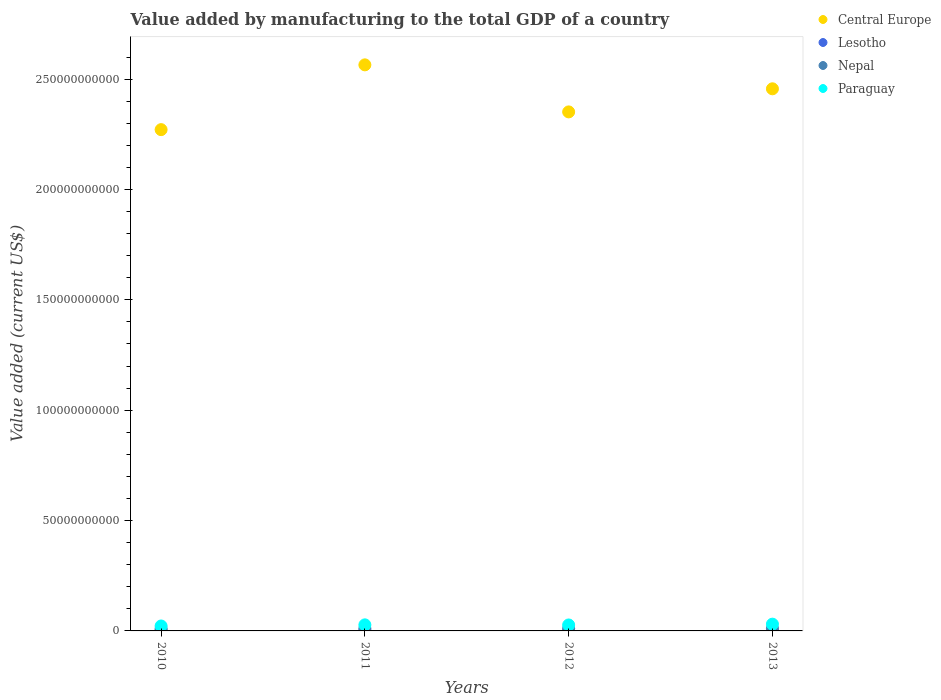How many different coloured dotlines are there?
Keep it short and to the point. 4. What is the value added by manufacturing to the total GDP in Central Europe in 2010?
Your answer should be compact. 2.27e+11. Across all years, what is the maximum value added by manufacturing to the total GDP in Nepal?
Keep it short and to the point. 1.14e+09. Across all years, what is the minimum value added by manufacturing to the total GDP in Central Europe?
Make the answer very short. 2.27e+11. What is the total value added by manufacturing to the total GDP in Paraguay in the graph?
Provide a succinct answer. 1.08e+1. What is the difference between the value added by manufacturing to the total GDP in Lesotho in 2010 and that in 2013?
Offer a terse response. 7.15e+07. What is the difference between the value added by manufacturing to the total GDP in Central Europe in 2013 and the value added by manufacturing to the total GDP in Paraguay in 2010?
Your answer should be very brief. 2.43e+11. What is the average value added by manufacturing to the total GDP in Central Europe per year?
Ensure brevity in your answer.  2.41e+11. In the year 2011, what is the difference between the value added by manufacturing to the total GDP in Lesotho and value added by manufacturing to the total GDP in Central Europe?
Provide a short and direct response. -2.56e+11. In how many years, is the value added by manufacturing to the total GDP in Paraguay greater than 70000000000 US$?
Provide a short and direct response. 0. What is the ratio of the value added by manufacturing to the total GDP in Paraguay in 2011 to that in 2013?
Your answer should be very brief. 0.9. Is the value added by manufacturing to the total GDP in Central Europe in 2011 less than that in 2013?
Provide a short and direct response. No. What is the difference between the highest and the second highest value added by manufacturing to the total GDP in Central Europe?
Your response must be concise. 1.08e+1. What is the difference between the highest and the lowest value added by manufacturing to the total GDP in Lesotho?
Offer a terse response. 7.15e+07. Is it the case that in every year, the sum of the value added by manufacturing to the total GDP in Lesotho and value added by manufacturing to the total GDP in Central Europe  is greater than the value added by manufacturing to the total GDP in Paraguay?
Keep it short and to the point. Yes. How many dotlines are there?
Make the answer very short. 4. Are the values on the major ticks of Y-axis written in scientific E-notation?
Your answer should be compact. No. Does the graph contain any zero values?
Offer a terse response. No. Where does the legend appear in the graph?
Keep it short and to the point. Top right. What is the title of the graph?
Offer a terse response. Value added by manufacturing to the total GDP of a country. What is the label or title of the X-axis?
Your response must be concise. Years. What is the label or title of the Y-axis?
Offer a very short reply. Value added (current US$). What is the Value added (current US$) in Central Europe in 2010?
Your answer should be compact. 2.27e+11. What is the Value added (current US$) of Lesotho in 2010?
Offer a terse response. 2.76e+08. What is the Value added (current US$) in Nepal in 2010?
Offer a terse response. 9.52e+08. What is the Value added (current US$) of Paraguay in 2010?
Your answer should be very brief. 2.24e+09. What is the Value added (current US$) of Central Europe in 2011?
Your response must be concise. 2.56e+11. What is the Value added (current US$) of Lesotho in 2011?
Offer a terse response. 2.64e+08. What is the Value added (current US$) of Nepal in 2011?
Your answer should be very brief. 1.11e+09. What is the Value added (current US$) in Paraguay in 2011?
Ensure brevity in your answer.  2.75e+09. What is the Value added (current US$) of Central Europe in 2012?
Provide a succinct answer. 2.35e+11. What is the Value added (current US$) of Lesotho in 2012?
Give a very brief answer. 2.41e+08. What is the Value added (current US$) of Nepal in 2012?
Offer a terse response. 1.13e+09. What is the Value added (current US$) in Paraguay in 2012?
Keep it short and to the point. 2.70e+09. What is the Value added (current US$) in Central Europe in 2013?
Your response must be concise. 2.46e+11. What is the Value added (current US$) in Lesotho in 2013?
Your answer should be compact. 2.04e+08. What is the Value added (current US$) in Nepal in 2013?
Your answer should be compact. 1.14e+09. What is the Value added (current US$) in Paraguay in 2013?
Make the answer very short. 3.06e+09. Across all years, what is the maximum Value added (current US$) in Central Europe?
Your answer should be compact. 2.56e+11. Across all years, what is the maximum Value added (current US$) of Lesotho?
Offer a terse response. 2.76e+08. Across all years, what is the maximum Value added (current US$) in Nepal?
Keep it short and to the point. 1.14e+09. Across all years, what is the maximum Value added (current US$) in Paraguay?
Provide a short and direct response. 3.06e+09. Across all years, what is the minimum Value added (current US$) of Central Europe?
Ensure brevity in your answer.  2.27e+11. Across all years, what is the minimum Value added (current US$) of Lesotho?
Give a very brief answer. 2.04e+08. Across all years, what is the minimum Value added (current US$) of Nepal?
Make the answer very short. 9.52e+08. Across all years, what is the minimum Value added (current US$) of Paraguay?
Offer a very short reply. 2.24e+09. What is the total Value added (current US$) of Central Europe in the graph?
Provide a short and direct response. 9.64e+11. What is the total Value added (current US$) in Lesotho in the graph?
Offer a very short reply. 9.85e+08. What is the total Value added (current US$) in Nepal in the graph?
Make the answer very short. 4.33e+09. What is the total Value added (current US$) of Paraguay in the graph?
Keep it short and to the point. 1.08e+1. What is the difference between the Value added (current US$) in Central Europe in 2010 and that in 2011?
Offer a very short reply. -2.93e+1. What is the difference between the Value added (current US$) of Lesotho in 2010 and that in 2011?
Offer a very short reply. 1.19e+07. What is the difference between the Value added (current US$) of Nepal in 2010 and that in 2011?
Provide a short and direct response. -1.63e+08. What is the difference between the Value added (current US$) in Paraguay in 2010 and that in 2011?
Your response must be concise. -5.10e+08. What is the difference between the Value added (current US$) in Central Europe in 2010 and that in 2012?
Your answer should be compact. -8.04e+09. What is the difference between the Value added (current US$) of Lesotho in 2010 and that in 2012?
Keep it short and to the point. 3.45e+07. What is the difference between the Value added (current US$) in Nepal in 2010 and that in 2012?
Your answer should be very brief. -1.74e+08. What is the difference between the Value added (current US$) in Paraguay in 2010 and that in 2012?
Keep it short and to the point. -4.61e+08. What is the difference between the Value added (current US$) of Central Europe in 2010 and that in 2013?
Provide a short and direct response. -1.85e+1. What is the difference between the Value added (current US$) in Lesotho in 2010 and that in 2013?
Provide a short and direct response. 7.15e+07. What is the difference between the Value added (current US$) in Nepal in 2010 and that in 2013?
Provide a succinct answer. -1.89e+08. What is the difference between the Value added (current US$) of Paraguay in 2010 and that in 2013?
Offer a very short reply. -8.23e+08. What is the difference between the Value added (current US$) of Central Europe in 2011 and that in 2012?
Ensure brevity in your answer.  2.13e+1. What is the difference between the Value added (current US$) in Lesotho in 2011 and that in 2012?
Keep it short and to the point. 2.26e+07. What is the difference between the Value added (current US$) of Nepal in 2011 and that in 2012?
Offer a very short reply. -1.10e+07. What is the difference between the Value added (current US$) of Paraguay in 2011 and that in 2012?
Make the answer very short. 4.88e+07. What is the difference between the Value added (current US$) in Central Europe in 2011 and that in 2013?
Your answer should be very brief. 1.08e+1. What is the difference between the Value added (current US$) of Lesotho in 2011 and that in 2013?
Your answer should be compact. 5.96e+07. What is the difference between the Value added (current US$) of Nepal in 2011 and that in 2013?
Make the answer very short. -2.62e+07. What is the difference between the Value added (current US$) of Paraguay in 2011 and that in 2013?
Your answer should be very brief. -3.13e+08. What is the difference between the Value added (current US$) in Central Europe in 2012 and that in 2013?
Keep it short and to the point. -1.05e+1. What is the difference between the Value added (current US$) in Lesotho in 2012 and that in 2013?
Your answer should be compact. 3.70e+07. What is the difference between the Value added (current US$) of Nepal in 2012 and that in 2013?
Provide a succinct answer. -1.53e+07. What is the difference between the Value added (current US$) of Paraguay in 2012 and that in 2013?
Give a very brief answer. -3.62e+08. What is the difference between the Value added (current US$) of Central Europe in 2010 and the Value added (current US$) of Lesotho in 2011?
Make the answer very short. 2.27e+11. What is the difference between the Value added (current US$) in Central Europe in 2010 and the Value added (current US$) in Nepal in 2011?
Ensure brevity in your answer.  2.26e+11. What is the difference between the Value added (current US$) in Central Europe in 2010 and the Value added (current US$) in Paraguay in 2011?
Your answer should be very brief. 2.24e+11. What is the difference between the Value added (current US$) in Lesotho in 2010 and the Value added (current US$) in Nepal in 2011?
Your response must be concise. -8.38e+08. What is the difference between the Value added (current US$) in Lesotho in 2010 and the Value added (current US$) in Paraguay in 2011?
Your answer should be very brief. -2.47e+09. What is the difference between the Value added (current US$) in Nepal in 2010 and the Value added (current US$) in Paraguay in 2011?
Your response must be concise. -1.80e+09. What is the difference between the Value added (current US$) in Central Europe in 2010 and the Value added (current US$) in Lesotho in 2012?
Keep it short and to the point. 2.27e+11. What is the difference between the Value added (current US$) of Central Europe in 2010 and the Value added (current US$) of Nepal in 2012?
Your answer should be very brief. 2.26e+11. What is the difference between the Value added (current US$) of Central Europe in 2010 and the Value added (current US$) of Paraguay in 2012?
Offer a very short reply. 2.24e+11. What is the difference between the Value added (current US$) of Lesotho in 2010 and the Value added (current US$) of Nepal in 2012?
Give a very brief answer. -8.49e+08. What is the difference between the Value added (current US$) in Lesotho in 2010 and the Value added (current US$) in Paraguay in 2012?
Your response must be concise. -2.42e+09. What is the difference between the Value added (current US$) of Nepal in 2010 and the Value added (current US$) of Paraguay in 2012?
Provide a succinct answer. -1.75e+09. What is the difference between the Value added (current US$) in Central Europe in 2010 and the Value added (current US$) in Lesotho in 2013?
Provide a succinct answer. 2.27e+11. What is the difference between the Value added (current US$) in Central Europe in 2010 and the Value added (current US$) in Nepal in 2013?
Your answer should be very brief. 2.26e+11. What is the difference between the Value added (current US$) in Central Europe in 2010 and the Value added (current US$) in Paraguay in 2013?
Provide a short and direct response. 2.24e+11. What is the difference between the Value added (current US$) in Lesotho in 2010 and the Value added (current US$) in Nepal in 2013?
Keep it short and to the point. -8.65e+08. What is the difference between the Value added (current US$) in Lesotho in 2010 and the Value added (current US$) in Paraguay in 2013?
Keep it short and to the point. -2.79e+09. What is the difference between the Value added (current US$) of Nepal in 2010 and the Value added (current US$) of Paraguay in 2013?
Keep it short and to the point. -2.11e+09. What is the difference between the Value added (current US$) in Central Europe in 2011 and the Value added (current US$) in Lesotho in 2012?
Offer a very short reply. 2.56e+11. What is the difference between the Value added (current US$) in Central Europe in 2011 and the Value added (current US$) in Nepal in 2012?
Offer a terse response. 2.55e+11. What is the difference between the Value added (current US$) of Central Europe in 2011 and the Value added (current US$) of Paraguay in 2012?
Provide a short and direct response. 2.54e+11. What is the difference between the Value added (current US$) in Lesotho in 2011 and the Value added (current US$) in Nepal in 2012?
Ensure brevity in your answer.  -8.61e+08. What is the difference between the Value added (current US$) in Lesotho in 2011 and the Value added (current US$) in Paraguay in 2012?
Your answer should be compact. -2.44e+09. What is the difference between the Value added (current US$) of Nepal in 2011 and the Value added (current US$) of Paraguay in 2012?
Make the answer very short. -1.59e+09. What is the difference between the Value added (current US$) in Central Europe in 2011 and the Value added (current US$) in Lesotho in 2013?
Keep it short and to the point. 2.56e+11. What is the difference between the Value added (current US$) of Central Europe in 2011 and the Value added (current US$) of Nepal in 2013?
Provide a short and direct response. 2.55e+11. What is the difference between the Value added (current US$) of Central Europe in 2011 and the Value added (current US$) of Paraguay in 2013?
Your answer should be compact. 2.53e+11. What is the difference between the Value added (current US$) in Lesotho in 2011 and the Value added (current US$) in Nepal in 2013?
Offer a very short reply. -8.77e+08. What is the difference between the Value added (current US$) of Lesotho in 2011 and the Value added (current US$) of Paraguay in 2013?
Provide a short and direct response. -2.80e+09. What is the difference between the Value added (current US$) in Nepal in 2011 and the Value added (current US$) in Paraguay in 2013?
Your answer should be very brief. -1.95e+09. What is the difference between the Value added (current US$) of Central Europe in 2012 and the Value added (current US$) of Lesotho in 2013?
Give a very brief answer. 2.35e+11. What is the difference between the Value added (current US$) in Central Europe in 2012 and the Value added (current US$) in Nepal in 2013?
Your answer should be compact. 2.34e+11. What is the difference between the Value added (current US$) of Central Europe in 2012 and the Value added (current US$) of Paraguay in 2013?
Offer a terse response. 2.32e+11. What is the difference between the Value added (current US$) of Lesotho in 2012 and the Value added (current US$) of Nepal in 2013?
Give a very brief answer. -8.99e+08. What is the difference between the Value added (current US$) of Lesotho in 2012 and the Value added (current US$) of Paraguay in 2013?
Offer a terse response. -2.82e+09. What is the difference between the Value added (current US$) of Nepal in 2012 and the Value added (current US$) of Paraguay in 2013?
Offer a terse response. -1.94e+09. What is the average Value added (current US$) in Central Europe per year?
Your response must be concise. 2.41e+11. What is the average Value added (current US$) in Lesotho per year?
Keep it short and to the point. 2.46e+08. What is the average Value added (current US$) in Nepal per year?
Offer a terse response. 1.08e+09. What is the average Value added (current US$) of Paraguay per year?
Ensure brevity in your answer.  2.69e+09. In the year 2010, what is the difference between the Value added (current US$) of Central Europe and Value added (current US$) of Lesotho?
Provide a succinct answer. 2.27e+11. In the year 2010, what is the difference between the Value added (current US$) in Central Europe and Value added (current US$) in Nepal?
Keep it short and to the point. 2.26e+11. In the year 2010, what is the difference between the Value added (current US$) in Central Europe and Value added (current US$) in Paraguay?
Provide a succinct answer. 2.25e+11. In the year 2010, what is the difference between the Value added (current US$) of Lesotho and Value added (current US$) of Nepal?
Ensure brevity in your answer.  -6.76e+08. In the year 2010, what is the difference between the Value added (current US$) in Lesotho and Value added (current US$) in Paraguay?
Ensure brevity in your answer.  -1.96e+09. In the year 2010, what is the difference between the Value added (current US$) in Nepal and Value added (current US$) in Paraguay?
Provide a succinct answer. -1.29e+09. In the year 2011, what is the difference between the Value added (current US$) in Central Europe and Value added (current US$) in Lesotho?
Your response must be concise. 2.56e+11. In the year 2011, what is the difference between the Value added (current US$) in Central Europe and Value added (current US$) in Nepal?
Make the answer very short. 2.55e+11. In the year 2011, what is the difference between the Value added (current US$) of Central Europe and Value added (current US$) of Paraguay?
Provide a short and direct response. 2.54e+11. In the year 2011, what is the difference between the Value added (current US$) of Lesotho and Value added (current US$) of Nepal?
Offer a very short reply. -8.50e+08. In the year 2011, what is the difference between the Value added (current US$) of Lesotho and Value added (current US$) of Paraguay?
Give a very brief answer. -2.49e+09. In the year 2011, what is the difference between the Value added (current US$) in Nepal and Value added (current US$) in Paraguay?
Give a very brief answer. -1.63e+09. In the year 2012, what is the difference between the Value added (current US$) in Central Europe and Value added (current US$) in Lesotho?
Make the answer very short. 2.35e+11. In the year 2012, what is the difference between the Value added (current US$) of Central Europe and Value added (current US$) of Nepal?
Ensure brevity in your answer.  2.34e+11. In the year 2012, what is the difference between the Value added (current US$) in Central Europe and Value added (current US$) in Paraguay?
Make the answer very short. 2.32e+11. In the year 2012, what is the difference between the Value added (current US$) of Lesotho and Value added (current US$) of Nepal?
Your answer should be compact. -8.84e+08. In the year 2012, what is the difference between the Value added (current US$) in Lesotho and Value added (current US$) in Paraguay?
Your answer should be compact. -2.46e+09. In the year 2012, what is the difference between the Value added (current US$) in Nepal and Value added (current US$) in Paraguay?
Ensure brevity in your answer.  -1.58e+09. In the year 2013, what is the difference between the Value added (current US$) of Central Europe and Value added (current US$) of Lesotho?
Provide a short and direct response. 2.45e+11. In the year 2013, what is the difference between the Value added (current US$) of Central Europe and Value added (current US$) of Nepal?
Make the answer very short. 2.44e+11. In the year 2013, what is the difference between the Value added (current US$) in Central Europe and Value added (current US$) in Paraguay?
Make the answer very short. 2.43e+11. In the year 2013, what is the difference between the Value added (current US$) of Lesotho and Value added (current US$) of Nepal?
Provide a succinct answer. -9.36e+08. In the year 2013, what is the difference between the Value added (current US$) of Lesotho and Value added (current US$) of Paraguay?
Your answer should be compact. -2.86e+09. In the year 2013, what is the difference between the Value added (current US$) of Nepal and Value added (current US$) of Paraguay?
Make the answer very short. -1.92e+09. What is the ratio of the Value added (current US$) of Central Europe in 2010 to that in 2011?
Provide a short and direct response. 0.89. What is the ratio of the Value added (current US$) in Lesotho in 2010 to that in 2011?
Provide a succinct answer. 1.05. What is the ratio of the Value added (current US$) of Nepal in 2010 to that in 2011?
Provide a succinct answer. 0.85. What is the ratio of the Value added (current US$) of Paraguay in 2010 to that in 2011?
Your answer should be compact. 0.81. What is the ratio of the Value added (current US$) of Central Europe in 2010 to that in 2012?
Provide a succinct answer. 0.97. What is the ratio of the Value added (current US$) in Nepal in 2010 to that in 2012?
Your answer should be very brief. 0.85. What is the ratio of the Value added (current US$) of Paraguay in 2010 to that in 2012?
Your response must be concise. 0.83. What is the ratio of the Value added (current US$) of Central Europe in 2010 to that in 2013?
Give a very brief answer. 0.92. What is the ratio of the Value added (current US$) in Lesotho in 2010 to that in 2013?
Your response must be concise. 1.35. What is the ratio of the Value added (current US$) of Nepal in 2010 to that in 2013?
Your answer should be compact. 0.83. What is the ratio of the Value added (current US$) in Paraguay in 2010 to that in 2013?
Provide a short and direct response. 0.73. What is the ratio of the Value added (current US$) of Central Europe in 2011 to that in 2012?
Ensure brevity in your answer.  1.09. What is the ratio of the Value added (current US$) in Lesotho in 2011 to that in 2012?
Keep it short and to the point. 1.09. What is the ratio of the Value added (current US$) in Nepal in 2011 to that in 2012?
Provide a succinct answer. 0.99. What is the ratio of the Value added (current US$) in Paraguay in 2011 to that in 2012?
Your response must be concise. 1.02. What is the ratio of the Value added (current US$) in Central Europe in 2011 to that in 2013?
Provide a succinct answer. 1.04. What is the ratio of the Value added (current US$) of Lesotho in 2011 to that in 2013?
Provide a short and direct response. 1.29. What is the ratio of the Value added (current US$) of Paraguay in 2011 to that in 2013?
Provide a short and direct response. 0.9. What is the ratio of the Value added (current US$) in Central Europe in 2012 to that in 2013?
Provide a short and direct response. 0.96. What is the ratio of the Value added (current US$) in Lesotho in 2012 to that in 2013?
Your answer should be compact. 1.18. What is the ratio of the Value added (current US$) of Nepal in 2012 to that in 2013?
Ensure brevity in your answer.  0.99. What is the ratio of the Value added (current US$) in Paraguay in 2012 to that in 2013?
Make the answer very short. 0.88. What is the difference between the highest and the second highest Value added (current US$) of Central Europe?
Provide a succinct answer. 1.08e+1. What is the difference between the highest and the second highest Value added (current US$) in Lesotho?
Your answer should be very brief. 1.19e+07. What is the difference between the highest and the second highest Value added (current US$) of Nepal?
Offer a very short reply. 1.53e+07. What is the difference between the highest and the second highest Value added (current US$) in Paraguay?
Offer a very short reply. 3.13e+08. What is the difference between the highest and the lowest Value added (current US$) in Central Europe?
Ensure brevity in your answer.  2.93e+1. What is the difference between the highest and the lowest Value added (current US$) in Lesotho?
Provide a short and direct response. 7.15e+07. What is the difference between the highest and the lowest Value added (current US$) of Nepal?
Your response must be concise. 1.89e+08. What is the difference between the highest and the lowest Value added (current US$) of Paraguay?
Your answer should be very brief. 8.23e+08. 